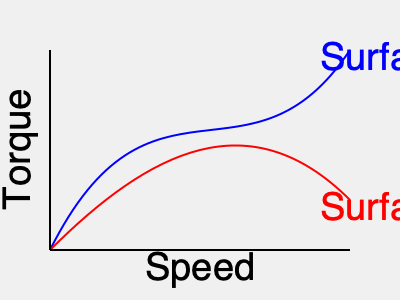Given the torque-speed curves for two different surfaces (A and B) as shown in the graph, which energy-efficient motor control strategy would you recommend for an autonomous vehicle traversing from Surface A to Surface B, and why? To determine the most energy-efficient motor control strategy, we need to analyze the torque-speed curves for both surfaces:

1. Surface A (blue curve):
   - High torque at low speeds
   - Rapidly decreasing torque as speed increases

2. Surface B (red curve):
   - Lower initial torque
   - More gradual decrease in torque as speed increases

The transition from Surface A to Surface B requires adapting the motor control strategy:

1. On Surface A:
   - Use high torque at low speeds to overcome initial resistance
   - Gradually increase speed while reducing torque

2. Transitioning to Surface B:
   - Reduce torque to match the lower requirements of Surface B
   - Increase speed to maintain efficiency

3. On Surface B:
   - Operate at a higher speed with lower torque
   - Maintain a balance between speed and torque for optimal efficiency

The most energy-efficient strategy would be to implement a dynamic torque-speed control system that:

a) Uses sensor data to detect surface changes
b) Adjusts motor parameters in real-time
c) Employs a model predictive control (MPC) algorithm to optimize energy consumption

This strategy allows for:
- Smooth transitions between surfaces
- Minimized energy waste from excessive torque
- Maximized efficiency by operating at optimal points on each curve

The control system should aim to keep the operating point near the knee of each curve, where the product of torque and speed (power output) is maximized relative to energy input.
Answer: Implement a dynamic torque-speed control system with MPC, adjusting from high-torque/low-speed on Surface A to lower-torque/higher-speed on Surface B. 